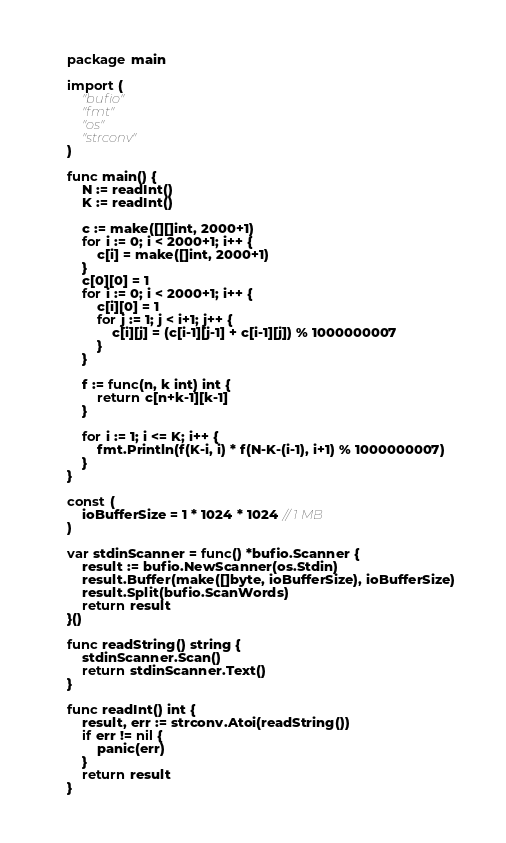<code> <loc_0><loc_0><loc_500><loc_500><_Go_>package main

import (
	"bufio"
	"fmt"
	"os"
	"strconv"
)

func main() {
	N := readInt()
	K := readInt()

	c := make([][]int, 2000+1)
	for i := 0; i < 2000+1; i++ {
		c[i] = make([]int, 2000+1)
	}
	c[0][0] = 1
	for i := 0; i < 2000+1; i++ {
		c[i][0] = 1
		for j := 1; j < i+1; j++ {
			c[i][j] = (c[i-1][j-1] + c[i-1][j]) % 1000000007
		}
	}

	f := func(n, k int) int {
		return c[n+k-1][k-1]
	}

	for i := 1; i <= K; i++ {
		fmt.Println(f(K-i, i) * f(N-K-(i-1), i+1) % 1000000007)
	}
}

const (
	ioBufferSize = 1 * 1024 * 1024 // 1 MB
)

var stdinScanner = func() *bufio.Scanner {
	result := bufio.NewScanner(os.Stdin)
	result.Buffer(make([]byte, ioBufferSize), ioBufferSize)
	result.Split(bufio.ScanWords)
	return result
}()

func readString() string {
	stdinScanner.Scan()
	return stdinScanner.Text()
}

func readInt() int {
	result, err := strconv.Atoi(readString())
	if err != nil {
		panic(err)
	}
	return result
}
</code> 